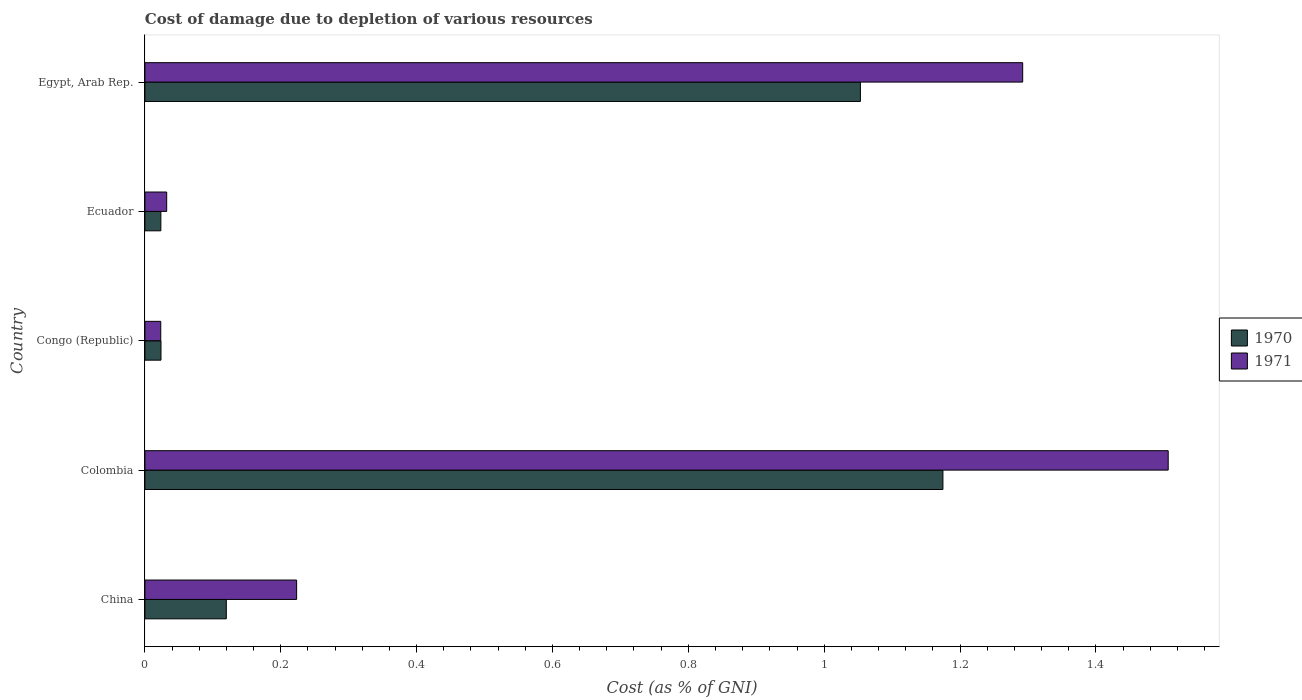Are the number of bars on each tick of the Y-axis equal?
Give a very brief answer. Yes. How many bars are there on the 5th tick from the top?
Your response must be concise. 2. How many bars are there on the 4th tick from the bottom?
Your response must be concise. 2. What is the label of the 1st group of bars from the top?
Your answer should be very brief. Egypt, Arab Rep. In how many cases, is the number of bars for a given country not equal to the number of legend labels?
Provide a short and direct response. 0. What is the cost of damage caused due to the depletion of various resources in 1971 in Colombia?
Keep it short and to the point. 1.51. Across all countries, what is the maximum cost of damage caused due to the depletion of various resources in 1970?
Provide a short and direct response. 1.17. Across all countries, what is the minimum cost of damage caused due to the depletion of various resources in 1971?
Ensure brevity in your answer.  0.02. In which country was the cost of damage caused due to the depletion of various resources in 1970 minimum?
Provide a succinct answer. Ecuador. What is the total cost of damage caused due to the depletion of various resources in 1970 in the graph?
Offer a very short reply. 2.4. What is the difference between the cost of damage caused due to the depletion of various resources in 1971 in China and that in Ecuador?
Your answer should be compact. 0.19. What is the difference between the cost of damage caused due to the depletion of various resources in 1971 in Egypt, Arab Rep. and the cost of damage caused due to the depletion of various resources in 1970 in Colombia?
Give a very brief answer. 0.12. What is the average cost of damage caused due to the depletion of various resources in 1970 per country?
Offer a very short reply. 0.48. What is the difference between the cost of damage caused due to the depletion of various resources in 1970 and cost of damage caused due to the depletion of various resources in 1971 in Congo (Republic)?
Your answer should be compact. 0. In how many countries, is the cost of damage caused due to the depletion of various resources in 1971 greater than 1 %?
Make the answer very short. 2. What is the ratio of the cost of damage caused due to the depletion of various resources in 1970 in Congo (Republic) to that in Ecuador?
Your response must be concise. 1.01. What is the difference between the highest and the second highest cost of damage caused due to the depletion of various resources in 1970?
Offer a very short reply. 0.12. What is the difference between the highest and the lowest cost of damage caused due to the depletion of various resources in 1971?
Your answer should be compact. 1.48. In how many countries, is the cost of damage caused due to the depletion of various resources in 1971 greater than the average cost of damage caused due to the depletion of various resources in 1971 taken over all countries?
Keep it short and to the point. 2. Is the sum of the cost of damage caused due to the depletion of various resources in 1970 in Colombia and Congo (Republic) greater than the maximum cost of damage caused due to the depletion of various resources in 1971 across all countries?
Your answer should be compact. No. What does the 1st bar from the top in Colombia represents?
Your answer should be very brief. 1971. What does the 2nd bar from the bottom in China represents?
Your response must be concise. 1971. Are all the bars in the graph horizontal?
Your answer should be compact. Yes. What is the difference between two consecutive major ticks on the X-axis?
Give a very brief answer. 0.2. Does the graph contain grids?
Offer a very short reply. No. Where does the legend appear in the graph?
Ensure brevity in your answer.  Center right. How many legend labels are there?
Make the answer very short. 2. How are the legend labels stacked?
Give a very brief answer. Vertical. What is the title of the graph?
Your answer should be very brief. Cost of damage due to depletion of various resources. Does "1997" appear as one of the legend labels in the graph?
Give a very brief answer. No. What is the label or title of the X-axis?
Offer a very short reply. Cost (as % of GNI). What is the label or title of the Y-axis?
Your answer should be compact. Country. What is the Cost (as % of GNI) of 1970 in China?
Make the answer very short. 0.12. What is the Cost (as % of GNI) in 1971 in China?
Provide a succinct answer. 0.22. What is the Cost (as % of GNI) in 1970 in Colombia?
Your answer should be compact. 1.17. What is the Cost (as % of GNI) in 1971 in Colombia?
Offer a terse response. 1.51. What is the Cost (as % of GNI) of 1970 in Congo (Republic)?
Provide a succinct answer. 0.02. What is the Cost (as % of GNI) in 1971 in Congo (Republic)?
Give a very brief answer. 0.02. What is the Cost (as % of GNI) in 1970 in Ecuador?
Ensure brevity in your answer.  0.02. What is the Cost (as % of GNI) in 1971 in Ecuador?
Give a very brief answer. 0.03. What is the Cost (as % of GNI) in 1970 in Egypt, Arab Rep.?
Provide a succinct answer. 1.05. What is the Cost (as % of GNI) in 1971 in Egypt, Arab Rep.?
Your response must be concise. 1.29. Across all countries, what is the maximum Cost (as % of GNI) in 1970?
Offer a terse response. 1.17. Across all countries, what is the maximum Cost (as % of GNI) in 1971?
Make the answer very short. 1.51. Across all countries, what is the minimum Cost (as % of GNI) in 1970?
Your answer should be compact. 0.02. Across all countries, what is the minimum Cost (as % of GNI) in 1971?
Your answer should be compact. 0.02. What is the total Cost (as % of GNI) in 1970 in the graph?
Offer a terse response. 2.4. What is the total Cost (as % of GNI) of 1971 in the graph?
Offer a very short reply. 3.08. What is the difference between the Cost (as % of GNI) of 1970 in China and that in Colombia?
Keep it short and to the point. -1.05. What is the difference between the Cost (as % of GNI) in 1971 in China and that in Colombia?
Provide a succinct answer. -1.28. What is the difference between the Cost (as % of GNI) in 1970 in China and that in Congo (Republic)?
Provide a short and direct response. 0.1. What is the difference between the Cost (as % of GNI) of 1971 in China and that in Congo (Republic)?
Give a very brief answer. 0.2. What is the difference between the Cost (as % of GNI) of 1970 in China and that in Ecuador?
Give a very brief answer. 0.1. What is the difference between the Cost (as % of GNI) of 1971 in China and that in Ecuador?
Make the answer very short. 0.19. What is the difference between the Cost (as % of GNI) of 1970 in China and that in Egypt, Arab Rep.?
Make the answer very short. -0.93. What is the difference between the Cost (as % of GNI) of 1971 in China and that in Egypt, Arab Rep.?
Provide a short and direct response. -1.07. What is the difference between the Cost (as % of GNI) in 1970 in Colombia and that in Congo (Republic)?
Provide a short and direct response. 1.15. What is the difference between the Cost (as % of GNI) of 1971 in Colombia and that in Congo (Republic)?
Make the answer very short. 1.48. What is the difference between the Cost (as % of GNI) of 1970 in Colombia and that in Ecuador?
Ensure brevity in your answer.  1.15. What is the difference between the Cost (as % of GNI) in 1971 in Colombia and that in Ecuador?
Provide a succinct answer. 1.47. What is the difference between the Cost (as % of GNI) of 1970 in Colombia and that in Egypt, Arab Rep.?
Offer a terse response. 0.12. What is the difference between the Cost (as % of GNI) in 1971 in Colombia and that in Egypt, Arab Rep.?
Make the answer very short. 0.21. What is the difference between the Cost (as % of GNI) in 1970 in Congo (Republic) and that in Ecuador?
Offer a terse response. 0. What is the difference between the Cost (as % of GNI) of 1971 in Congo (Republic) and that in Ecuador?
Provide a short and direct response. -0.01. What is the difference between the Cost (as % of GNI) in 1970 in Congo (Republic) and that in Egypt, Arab Rep.?
Offer a terse response. -1.03. What is the difference between the Cost (as % of GNI) in 1971 in Congo (Republic) and that in Egypt, Arab Rep.?
Offer a very short reply. -1.27. What is the difference between the Cost (as % of GNI) in 1970 in Ecuador and that in Egypt, Arab Rep.?
Make the answer very short. -1.03. What is the difference between the Cost (as % of GNI) of 1971 in Ecuador and that in Egypt, Arab Rep.?
Your answer should be compact. -1.26. What is the difference between the Cost (as % of GNI) of 1970 in China and the Cost (as % of GNI) of 1971 in Colombia?
Ensure brevity in your answer.  -1.39. What is the difference between the Cost (as % of GNI) of 1970 in China and the Cost (as % of GNI) of 1971 in Congo (Republic)?
Your answer should be very brief. 0.1. What is the difference between the Cost (as % of GNI) in 1970 in China and the Cost (as % of GNI) in 1971 in Ecuador?
Give a very brief answer. 0.09. What is the difference between the Cost (as % of GNI) of 1970 in China and the Cost (as % of GNI) of 1971 in Egypt, Arab Rep.?
Make the answer very short. -1.17. What is the difference between the Cost (as % of GNI) of 1970 in Colombia and the Cost (as % of GNI) of 1971 in Congo (Republic)?
Your answer should be compact. 1.15. What is the difference between the Cost (as % of GNI) in 1970 in Colombia and the Cost (as % of GNI) in 1971 in Ecuador?
Your answer should be compact. 1.14. What is the difference between the Cost (as % of GNI) of 1970 in Colombia and the Cost (as % of GNI) of 1971 in Egypt, Arab Rep.?
Provide a succinct answer. -0.12. What is the difference between the Cost (as % of GNI) in 1970 in Congo (Republic) and the Cost (as % of GNI) in 1971 in Ecuador?
Give a very brief answer. -0.01. What is the difference between the Cost (as % of GNI) in 1970 in Congo (Republic) and the Cost (as % of GNI) in 1971 in Egypt, Arab Rep.?
Your response must be concise. -1.27. What is the difference between the Cost (as % of GNI) of 1970 in Ecuador and the Cost (as % of GNI) of 1971 in Egypt, Arab Rep.?
Give a very brief answer. -1.27. What is the average Cost (as % of GNI) of 1970 per country?
Ensure brevity in your answer.  0.48. What is the average Cost (as % of GNI) of 1971 per country?
Offer a terse response. 0.62. What is the difference between the Cost (as % of GNI) in 1970 and Cost (as % of GNI) in 1971 in China?
Provide a succinct answer. -0.1. What is the difference between the Cost (as % of GNI) of 1970 and Cost (as % of GNI) of 1971 in Colombia?
Your response must be concise. -0.33. What is the difference between the Cost (as % of GNI) of 1970 and Cost (as % of GNI) of 1971 in Ecuador?
Make the answer very short. -0.01. What is the difference between the Cost (as % of GNI) in 1970 and Cost (as % of GNI) in 1971 in Egypt, Arab Rep.?
Provide a short and direct response. -0.24. What is the ratio of the Cost (as % of GNI) of 1970 in China to that in Colombia?
Ensure brevity in your answer.  0.1. What is the ratio of the Cost (as % of GNI) of 1971 in China to that in Colombia?
Make the answer very short. 0.15. What is the ratio of the Cost (as % of GNI) in 1970 in China to that in Congo (Republic)?
Offer a terse response. 5.07. What is the ratio of the Cost (as % of GNI) of 1971 in China to that in Congo (Republic)?
Offer a terse response. 9.58. What is the ratio of the Cost (as % of GNI) in 1970 in China to that in Ecuador?
Your answer should be very brief. 5.11. What is the ratio of the Cost (as % of GNI) in 1971 in China to that in Ecuador?
Ensure brevity in your answer.  6.97. What is the ratio of the Cost (as % of GNI) of 1970 in China to that in Egypt, Arab Rep.?
Keep it short and to the point. 0.11. What is the ratio of the Cost (as % of GNI) of 1971 in China to that in Egypt, Arab Rep.?
Your response must be concise. 0.17. What is the ratio of the Cost (as % of GNI) of 1970 in Colombia to that in Congo (Republic)?
Ensure brevity in your answer.  49.67. What is the ratio of the Cost (as % of GNI) in 1971 in Colombia to that in Congo (Republic)?
Your answer should be very brief. 64.63. What is the ratio of the Cost (as % of GNI) of 1970 in Colombia to that in Ecuador?
Keep it short and to the point. 50.08. What is the ratio of the Cost (as % of GNI) in 1971 in Colombia to that in Ecuador?
Offer a terse response. 47. What is the ratio of the Cost (as % of GNI) of 1970 in Colombia to that in Egypt, Arab Rep.?
Provide a succinct answer. 1.12. What is the ratio of the Cost (as % of GNI) in 1971 in Colombia to that in Egypt, Arab Rep.?
Your response must be concise. 1.17. What is the ratio of the Cost (as % of GNI) in 1970 in Congo (Republic) to that in Ecuador?
Keep it short and to the point. 1.01. What is the ratio of the Cost (as % of GNI) in 1971 in Congo (Republic) to that in Ecuador?
Offer a terse response. 0.73. What is the ratio of the Cost (as % of GNI) in 1970 in Congo (Republic) to that in Egypt, Arab Rep.?
Make the answer very short. 0.02. What is the ratio of the Cost (as % of GNI) in 1971 in Congo (Republic) to that in Egypt, Arab Rep.?
Make the answer very short. 0.02. What is the ratio of the Cost (as % of GNI) in 1970 in Ecuador to that in Egypt, Arab Rep.?
Offer a very short reply. 0.02. What is the ratio of the Cost (as % of GNI) of 1971 in Ecuador to that in Egypt, Arab Rep.?
Your answer should be compact. 0.02. What is the difference between the highest and the second highest Cost (as % of GNI) in 1970?
Give a very brief answer. 0.12. What is the difference between the highest and the second highest Cost (as % of GNI) in 1971?
Provide a succinct answer. 0.21. What is the difference between the highest and the lowest Cost (as % of GNI) in 1970?
Your answer should be very brief. 1.15. What is the difference between the highest and the lowest Cost (as % of GNI) of 1971?
Offer a terse response. 1.48. 